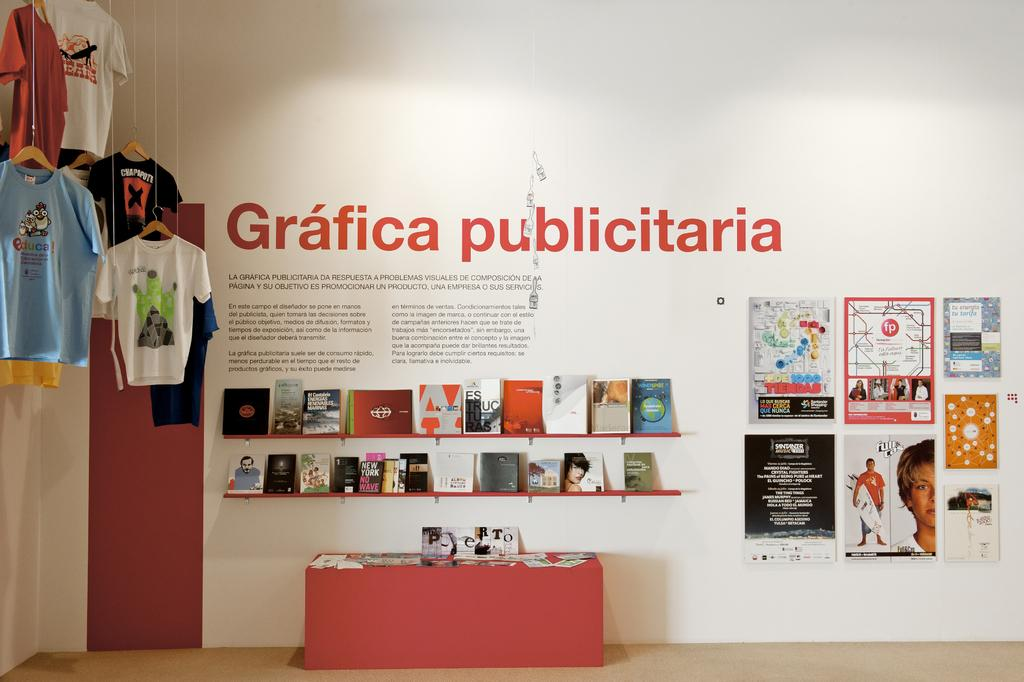<image>
Write a terse but informative summary of the picture. shirts hanging in a corner and wall with 2 shelves of books below Grafica publicitaria 